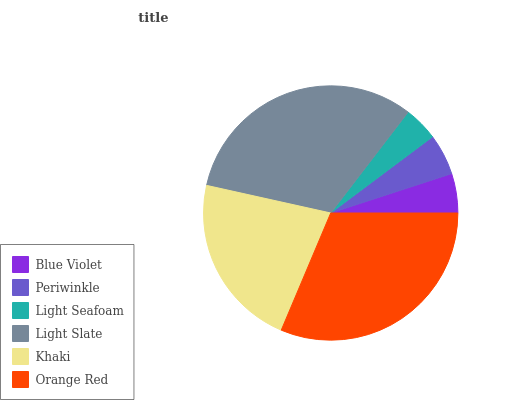Is Light Seafoam the minimum?
Answer yes or no. Yes. Is Light Slate the maximum?
Answer yes or no. Yes. Is Periwinkle the minimum?
Answer yes or no. No. Is Periwinkle the maximum?
Answer yes or no. No. Is Periwinkle greater than Blue Violet?
Answer yes or no. Yes. Is Blue Violet less than Periwinkle?
Answer yes or no. Yes. Is Blue Violet greater than Periwinkle?
Answer yes or no. No. Is Periwinkle less than Blue Violet?
Answer yes or no. No. Is Khaki the high median?
Answer yes or no. Yes. Is Periwinkle the low median?
Answer yes or no. Yes. Is Periwinkle the high median?
Answer yes or no. No. Is Light Slate the low median?
Answer yes or no. No. 